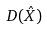<formula> <loc_0><loc_0><loc_500><loc_500>D ( \hat { X } )</formula> 